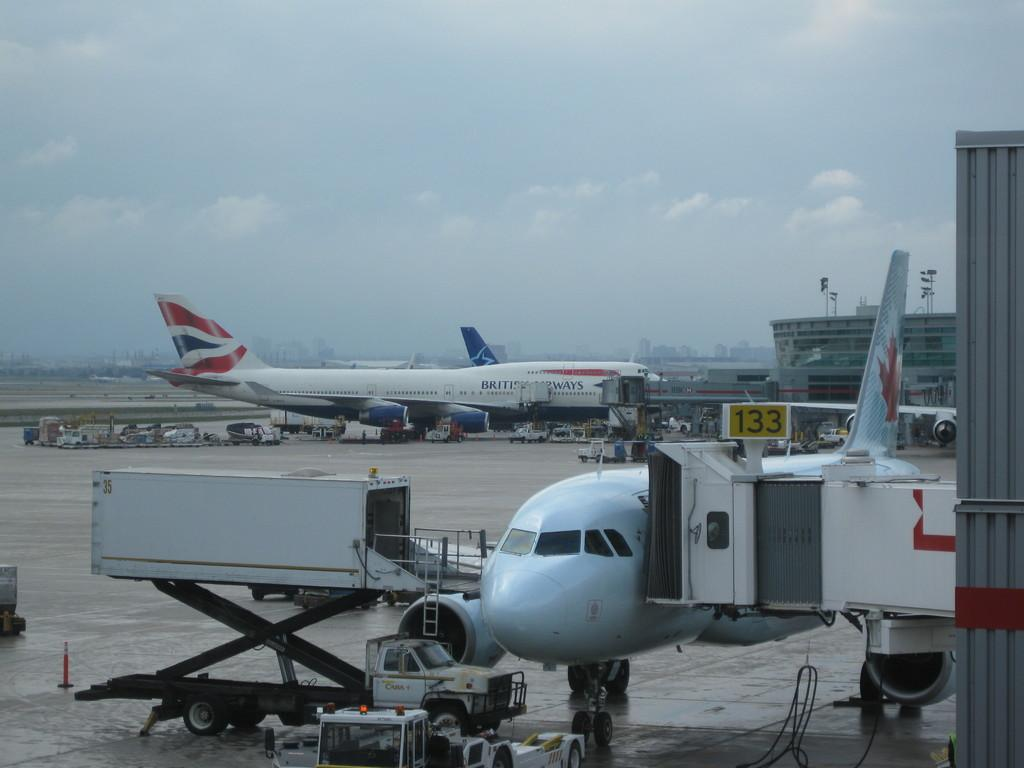<image>
Give a short and clear explanation of the subsequent image. It's a gloomy day on the tarmac, where commercial Canadian and British Airways jets are connected to covered, portable walkways for passengers to board the planes are parked. 